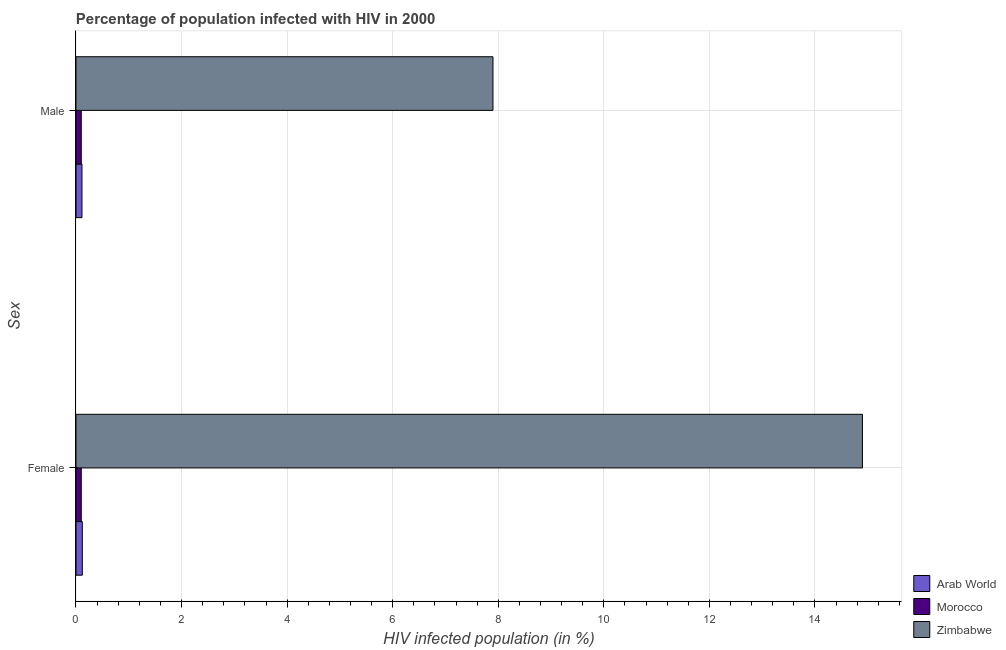How many groups of bars are there?
Ensure brevity in your answer.  2. Are the number of bars per tick equal to the number of legend labels?
Your answer should be very brief. Yes. How many bars are there on the 2nd tick from the bottom?
Keep it short and to the point. 3. What is the label of the 1st group of bars from the top?
Your response must be concise. Male. What is the percentage of males who are infected with hiv in Arab World?
Your response must be concise. 0.11. Across all countries, what is the minimum percentage of males who are infected with hiv?
Ensure brevity in your answer.  0.1. In which country was the percentage of females who are infected with hiv maximum?
Keep it short and to the point. Zimbabwe. In which country was the percentage of females who are infected with hiv minimum?
Ensure brevity in your answer.  Morocco. What is the total percentage of females who are infected with hiv in the graph?
Offer a very short reply. 15.12. What is the difference between the percentage of females who are infected with hiv in Arab World and that in Morocco?
Provide a succinct answer. 0.02. What is the difference between the percentage of females who are infected with hiv in Zimbabwe and the percentage of males who are infected with hiv in Arab World?
Your answer should be very brief. 14.79. What is the average percentage of males who are infected with hiv per country?
Offer a terse response. 2.7. What is the difference between the percentage of males who are infected with hiv and percentage of females who are infected with hiv in Zimbabwe?
Provide a short and direct response. -7. In how many countries, is the percentage of males who are infected with hiv greater than 6 %?
Make the answer very short. 1. What is the ratio of the percentage of males who are infected with hiv in Arab World to that in Morocco?
Your answer should be compact. 1.13. In how many countries, is the percentage of females who are infected with hiv greater than the average percentage of females who are infected with hiv taken over all countries?
Your answer should be compact. 1. What does the 2nd bar from the top in Male represents?
Your response must be concise. Morocco. What does the 2nd bar from the bottom in Male represents?
Give a very brief answer. Morocco. How many bars are there?
Ensure brevity in your answer.  6. Are all the bars in the graph horizontal?
Your answer should be very brief. Yes. How many countries are there in the graph?
Offer a very short reply. 3. What is the difference between two consecutive major ticks on the X-axis?
Give a very brief answer. 2. Does the graph contain grids?
Your answer should be compact. Yes. Where does the legend appear in the graph?
Your answer should be compact. Bottom right. How are the legend labels stacked?
Offer a very short reply. Vertical. What is the title of the graph?
Your answer should be compact. Percentage of population infected with HIV in 2000. Does "Namibia" appear as one of the legend labels in the graph?
Make the answer very short. No. What is the label or title of the X-axis?
Give a very brief answer. HIV infected population (in %). What is the label or title of the Y-axis?
Provide a short and direct response. Sex. What is the HIV infected population (in %) of Arab World in Female?
Make the answer very short. 0.12. What is the HIV infected population (in %) of Zimbabwe in Female?
Keep it short and to the point. 14.9. What is the HIV infected population (in %) of Arab World in Male?
Provide a short and direct response. 0.11. What is the HIV infected population (in %) in Morocco in Male?
Ensure brevity in your answer.  0.1. Across all Sex, what is the maximum HIV infected population (in %) of Arab World?
Offer a terse response. 0.12. Across all Sex, what is the minimum HIV infected population (in %) in Arab World?
Keep it short and to the point. 0.11. What is the total HIV infected population (in %) of Arab World in the graph?
Your answer should be very brief. 0.23. What is the total HIV infected population (in %) in Zimbabwe in the graph?
Your answer should be compact. 22.8. What is the difference between the HIV infected population (in %) in Arab World in Female and that in Male?
Keep it short and to the point. 0.01. What is the difference between the HIV infected population (in %) of Morocco in Female and that in Male?
Give a very brief answer. 0. What is the difference between the HIV infected population (in %) of Arab World in Female and the HIV infected population (in %) of Morocco in Male?
Give a very brief answer. 0.02. What is the difference between the HIV infected population (in %) in Arab World in Female and the HIV infected population (in %) in Zimbabwe in Male?
Provide a short and direct response. -7.78. What is the average HIV infected population (in %) of Arab World per Sex?
Offer a very short reply. 0.12. What is the average HIV infected population (in %) in Zimbabwe per Sex?
Make the answer very short. 11.4. What is the difference between the HIV infected population (in %) in Arab World and HIV infected population (in %) in Morocco in Female?
Offer a very short reply. 0.02. What is the difference between the HIV infected population (in %) of Arab World and HIV infected population (in %) of Zimbabwe in Female?
Provide a succinct answer. -14.78. What is the difference between the HIV infected population (in %) of Morocco and HIV infected population (in %) of Zimbabwe in Female?
Offer a very short reply. -14.8. What is the difference between the HIV infected population (in %) of Arab World and HIV infected population (in %) of Morocco in Male?
Make the answer very short. 0.01. What is the difference between the HIV infected population (in %) of Arab World and HIV infected population (in %) of Zimbabwe in Male?
Keep it short and to the point. -7.79. What is the difference between the HIV infected population (in %) in Morocco and HIV infected population (in %) in Zimbabwe in Male?
Provide a short and direct response. -7.8. What is the ratio of the HIV infected population (in %) in Arab World in Female to that in Male?
Give a very brief answer. 1.06. What is the ratio of the HIV infected population (in %) of Morocco in Female to that in Male?
Give a very brief answer. 1. What is the ratio of the HIV infected population (in %) of Zimbabwe in Female to that in Male?
Offer a terse response. 1.89. What is the difference between the highest and the second highest HIV infected population (in %) in Arab World?
Provide a short and direct response. 0.01. What is the difference between the highest and the second highest HIV infected population (in %) in Morocco?
Keep it short and to the point. 0. What is the difference between the highest and the lowest HIV infected population (in %) of Arab World?
Your answer should be very brief. 0.01. What is the difference between the highest and the lowest HIV infected population (in %) in Morocco?
Provide a short and direct response. 0. What is the difference between the highest and the lowest HIV infected population (in %) in Zimbabwe?
Offer a terse response. 7. 